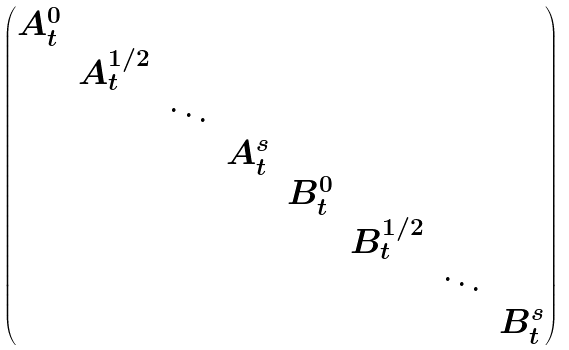Convert formula to latex. <formula><loc_0><loc_0><loc_500><loc_500>\begin{pmatrix} A ^ { 0 } _ { t } & & & & & & & \\ & A ^ { 1 / 2 } _ { t } & & & & & & \\ & & \ddots & & & & & \\ & & & A ^ { s } _ { t } & & & & \\ & & & & B ^ { 0 } _ { t } & & & \\ & & & & & B ^ { 1 / 2 } _ { t } & & \\ & & & & & & \ddots & \\ & & & & & & & B ^ { s } _ { t } \end{pmatrix}</formula> 